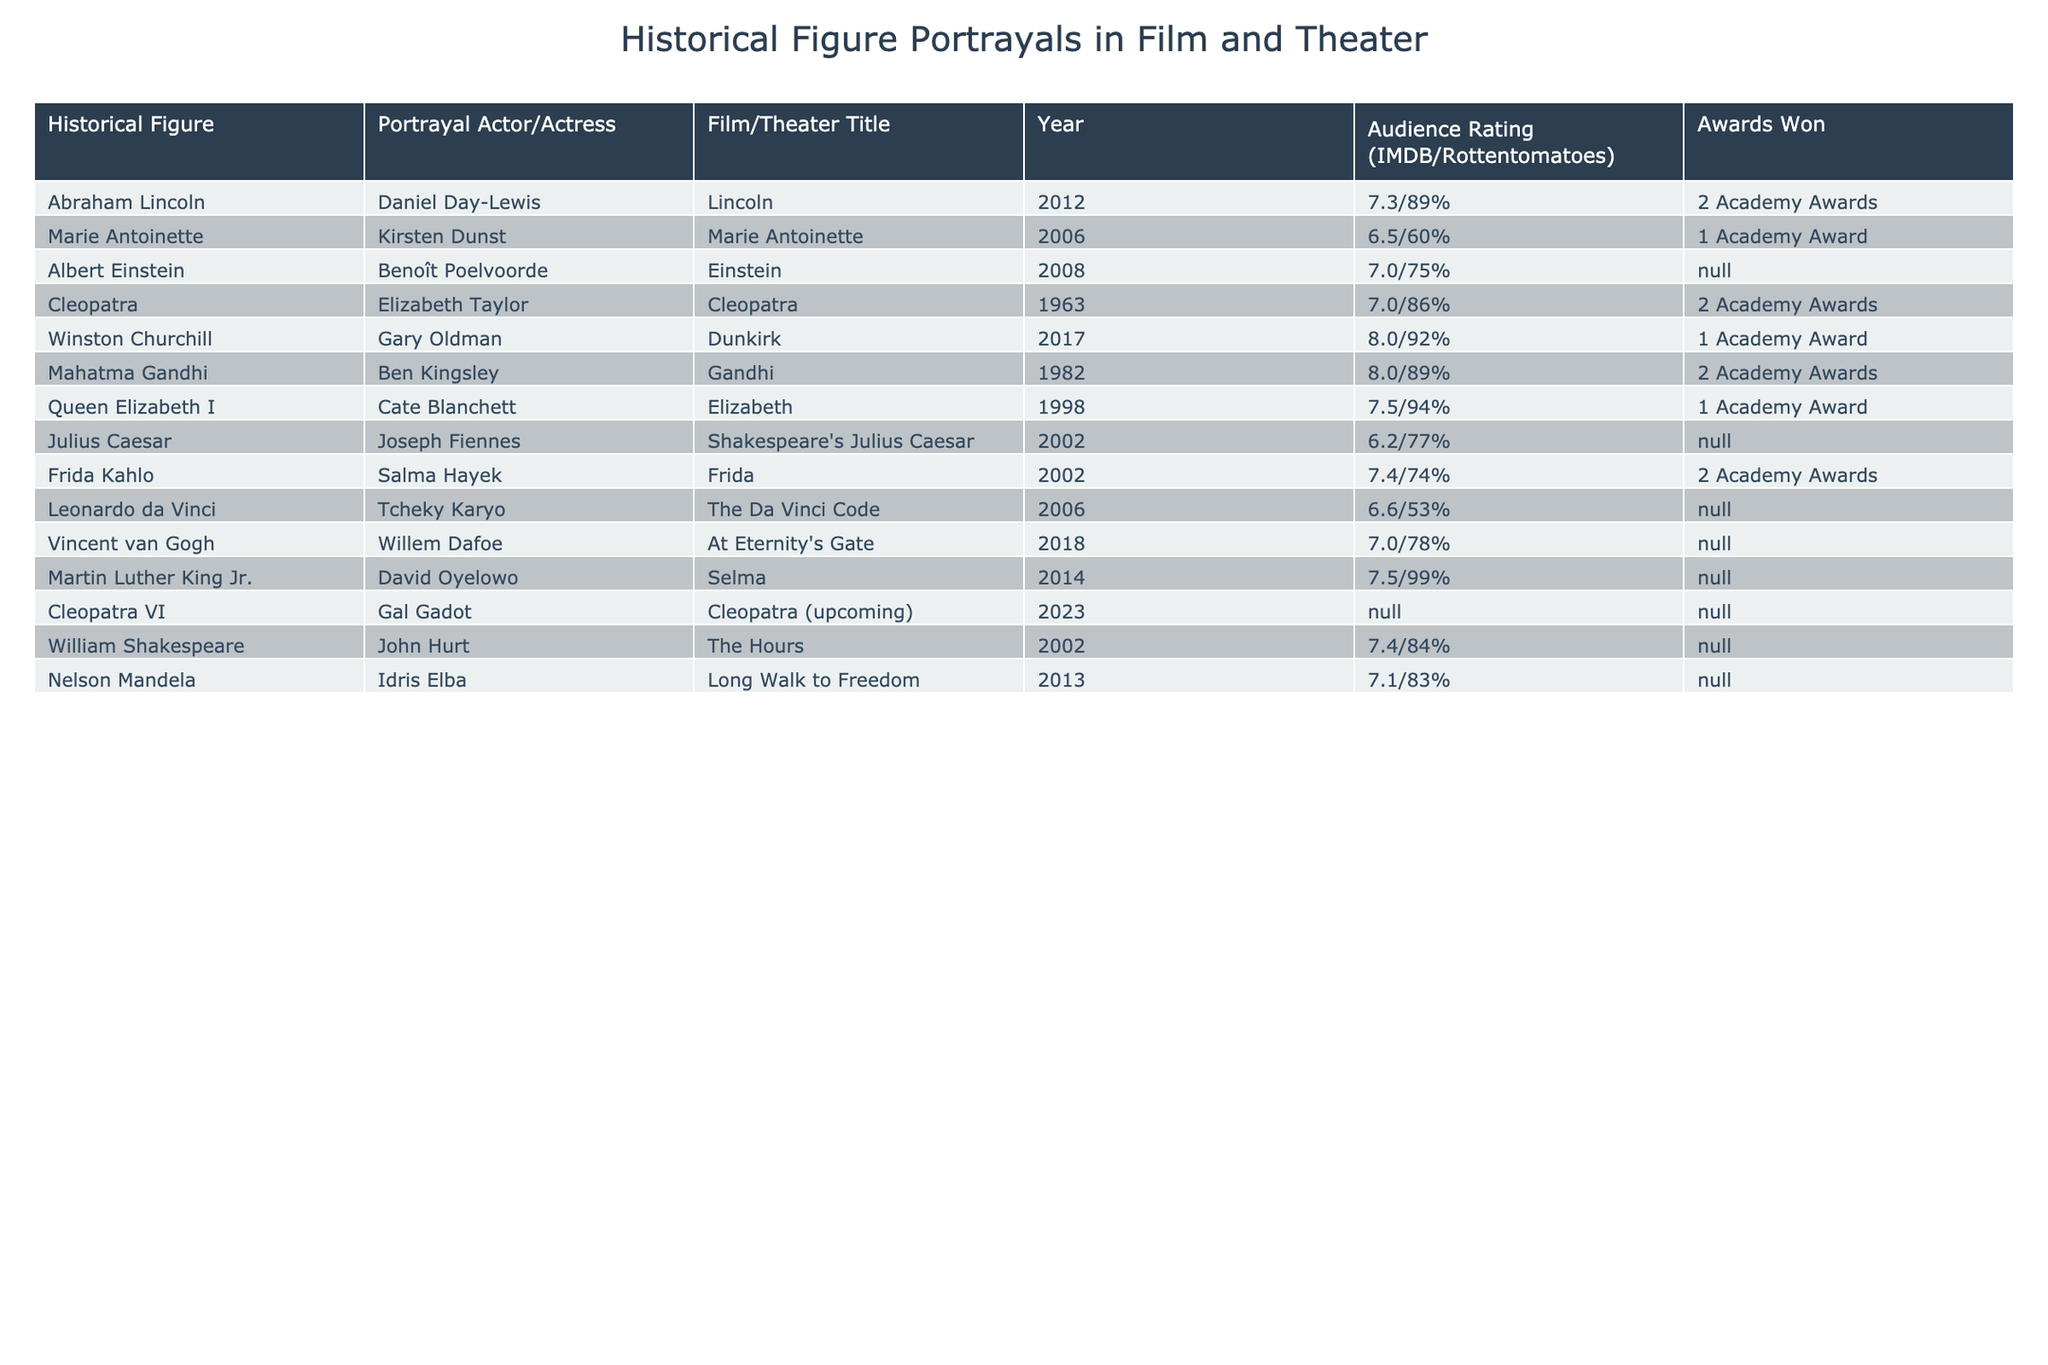What is the highest audience rating in the table? The highest audience rating can be found by examining the "Audience Rating" column. The highest rating is 8.0, which corresponds to the portrayal of Winston Churchill by Gary Oldman in the film Dunkirk.
Answer: 8.0 Who portrayed Marie Antoinette in the film Marie Antoinette? The table shows that Kirsten Dunst portrayed Marie Antoinette in the 2006 film.
Answer: Kirsten Dunst How many Academy Awards did Abraham Lincoln win? By looking at the "Awards Won" column for Abraham Lincoln's portrayal, it shows that Daniel Day-Lewis won 2 Academy Awards for the film Lincoln.
Answer: 2 Academy Awards Which portrayal has the lowest IMDB rating? The "Audience Rating" column can help determine the lowest value. The lowest IMDB rating is 6.2, which is for Julius Caesar portrayed by Joseph Fiennes.
Answer: 6.2 Is there any portrayal that has not won any awards? Checking the "Awards Won" column shows that several entries have "N/A," indicating they have not won any awards. This includes Albert Einstein, Julius Caesar, Vincent van Gogh, and others.
Answer: Yes What is the average audience rating for the portrayals that won two Academy Awards? The ratings for portrayals that won two Academy Awards are 7.3 (Lincoln), 8.0 (Gandhi), 7.4 (Frida), and 7.0 (Cleopatra). Their sum is 30.7. There are 4 entries, so the average is 30.7/4 = 7.675.
Answer: 7.675 How many portrayals have an audience rating above 7.5? The "Audience Rating" values above 7.5 are 8.0 (Winston Churchill), 8.0 (Mahatma Gandhi), and 7.5 (Martin Luther King Jr.), totaling three portrayals.
Answer: 3 Who is the only portrayal that has an audience rating of 6.5? From the table, Marie Antoinette by Kirsten Dunst has a rating of 6.5, which is the only instance in this category.
Answer: Kirsten Dunst What are the notable differences in awards between portrayals of Winston Churchill and Mahatma Gandhi? Winston Churchill won 1 Academy Award with an audience rating of 8.0, while Mahatma Gandhi won 2 Academy Awards with the same audience rating of 8.0. Therefore, Gandhi has one more award than Churchill.
Answer: Gandhi has more awards Is Cleopatra VI's portrayal expected to have an audience rating based on past portrayals of Cleopatra? The upcoming portrayal by Gal Gadot does not have an audience rating yet, but prior portrayals of Cleopatra, such as Elizabeth Taylor's, had ratings above 7.0. Thus, it may be reasonable to expect a favorable rating for Cleopatra VI.
Answer: Yes, it may be favorable 